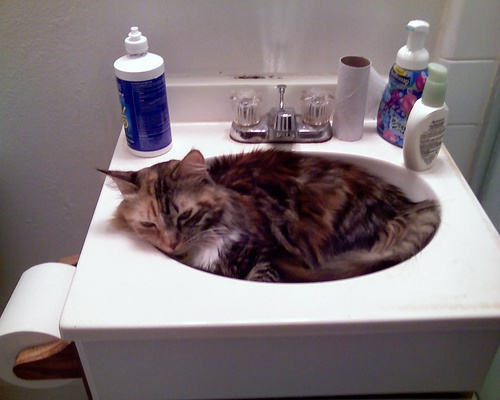Describe the objects in this image and their specific colors. I can see sink in gray, white, black, and maroon tones, cat in gray, black, maroon, and brown tones, and sink in gray, black, lightgray, and darkgray tones in this image. 